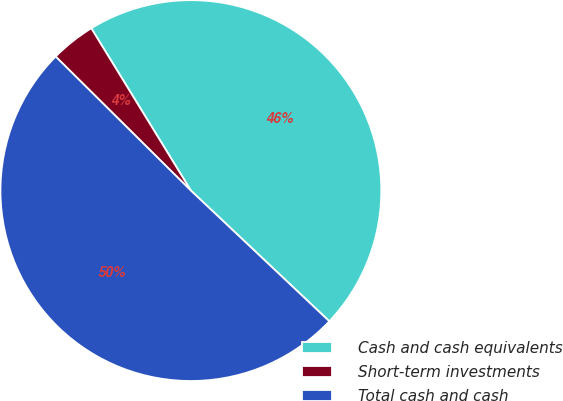<chart> <loc_0><loc_0><loc_500><loc_500><pie_chart><fcel>Cash and cash equivalents<fcel>Short-term investments<fcel>Total cash and cash<nl><fcel>45.8%<fcel>3.81%<fcel>50.38%<nl></chart> 